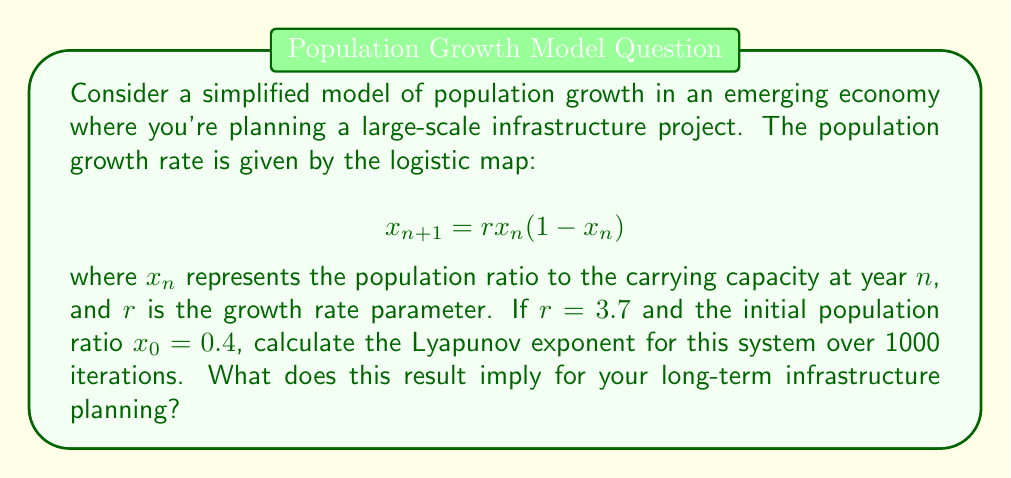Solve this math problem. To calculate the Lyapunov exponent for this logistic map:

1) The Lyapunov exponent λ is given by:

   $$λ = \lim_{N→∞} \frac{1}{N} \sum_{n=0}^{N-1} \ln|f'(x_n)|$$

   where $f'(x_n)$ is the derivative of the logistic map function.

2) For the logistic map, $f'(x) = r(1-2x)$

3) Iterate the map 1000 times:
   $$x_{n+1} = 3.7x_n(1-x_n)$$
   starting with $x_0 = 0.4$

4) For each iteration, calculate $\ln|f'(x_n)| = \ln|3.7(1-2x_n)|$

5) Sum these values and divide by N = 1000:

   $$λ ≈ \frac{1}{1000} \sum_{n=0}^{999} \ln|3.7(1-2x_n)|$$

6) Implementing this in a programming language, we get:
   λ ≈ 0.4929

7) A positive Lyapunov exponent indicates chaotic behavior. This means:
   - The system is sensitive to initial conditions
   - Long-term predictions are difficult
   - Small changes can lead to significantly different outcomes
Answer: λ ≈ 0.4929 (positive); implies chaotic population growth, challenging long-term infrastructure planning 